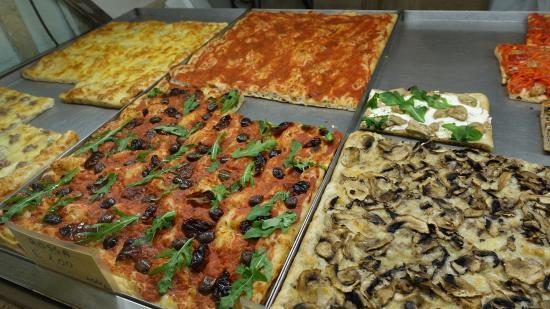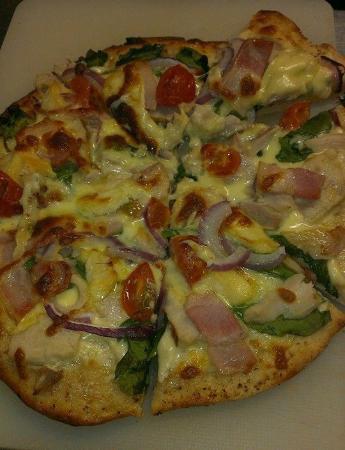The first image is the image on the left, the second image is the image on the right. Assess this claim about the two images: "At least one pizza has a slice cut out of it.". Correct or not? Answer yes or no. Yes. The first image is the image on the left, the second image is the image on the right. Examine the images to the left and right. Is the description "The left and right image contains the same number of circle shaped pizzas." accurate? Answer yes or no. No. 